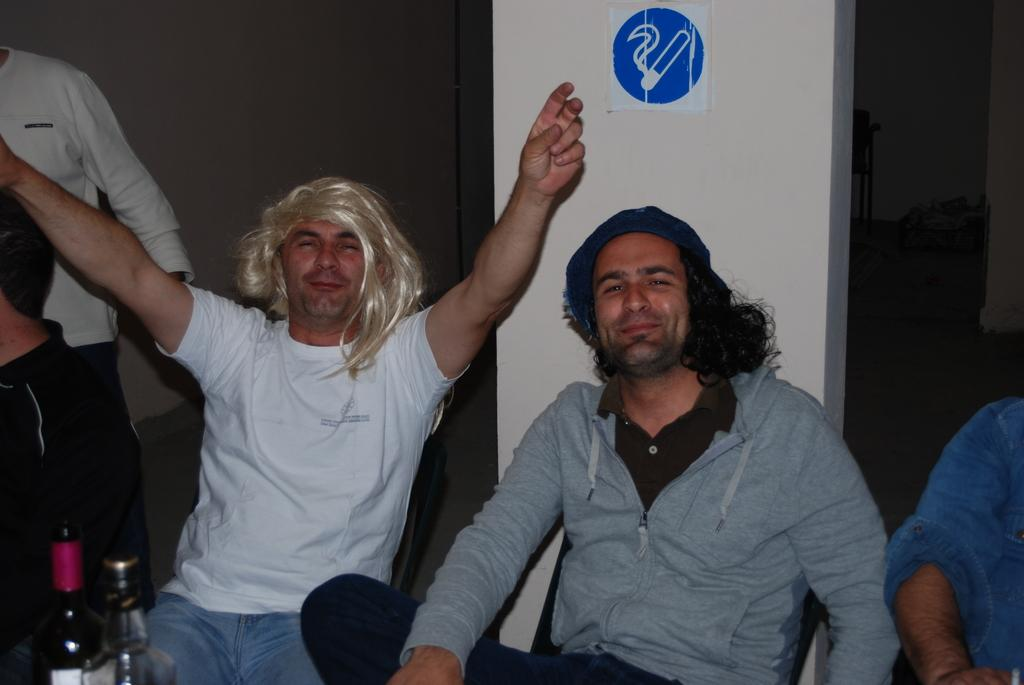What are the people in the image doing? The people in the image are sitting on chairs. What objects can be seen besides the chairs? There are bottles visible in the image. What is on the wall in the image? There is a signboard on the wall. What type of flower is growing on the floor in the image? There is no flower visible on the floor in the image. 